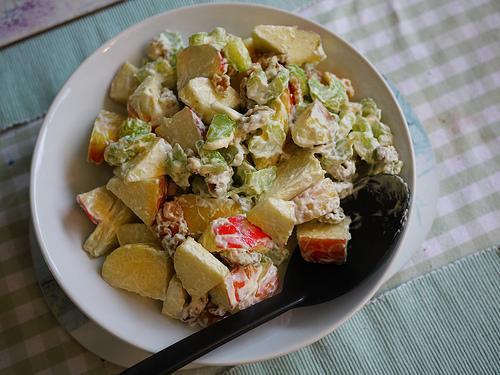How many bowls are on the table?
Give a very brief answer. 1. 